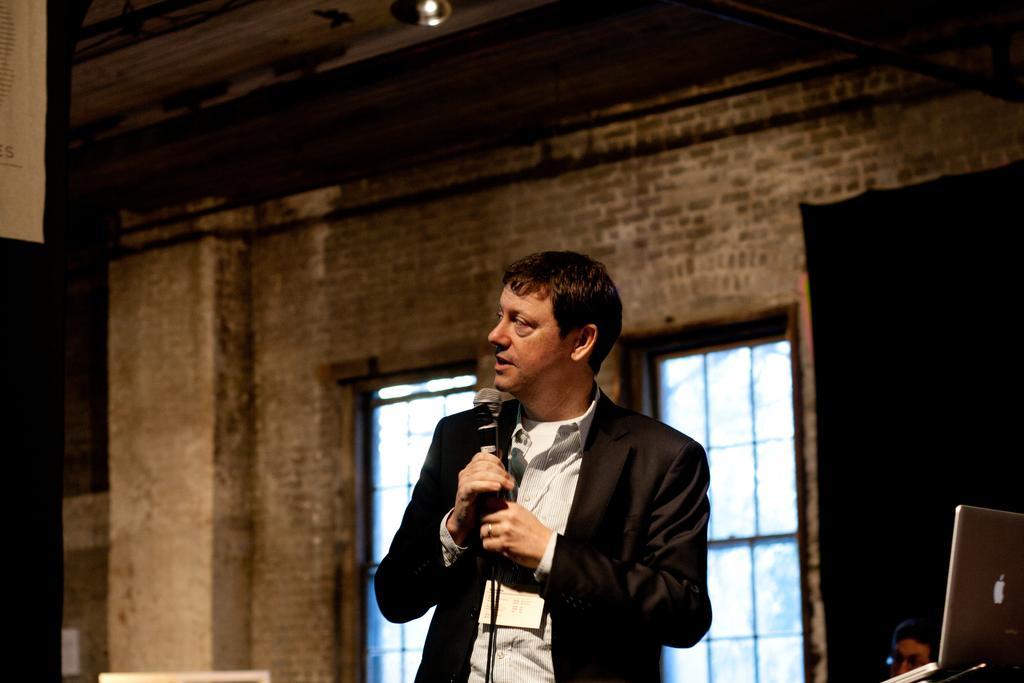Please provide a concise description of this image. In the image we can see there is a man who is standing and holding mic in his hand. 